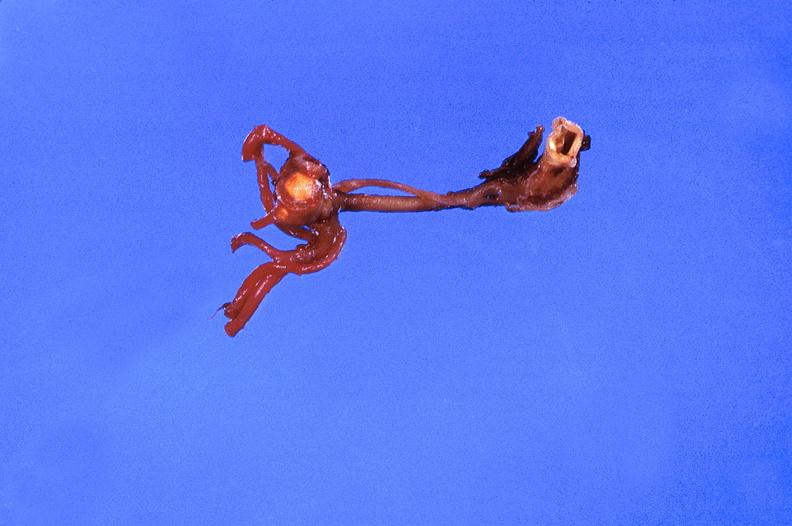what is present?
Answer the question using a single word or phrase. Vasculature 